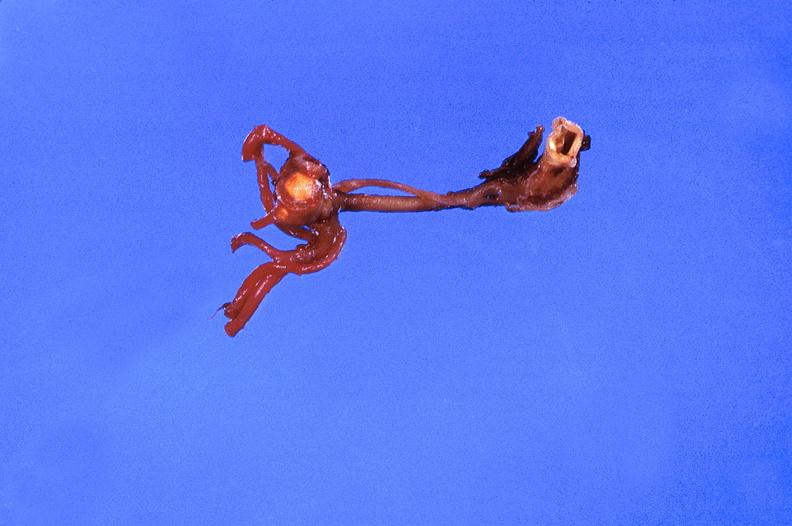what is present?
Answer the question using a single word or phrase. Vasculature 